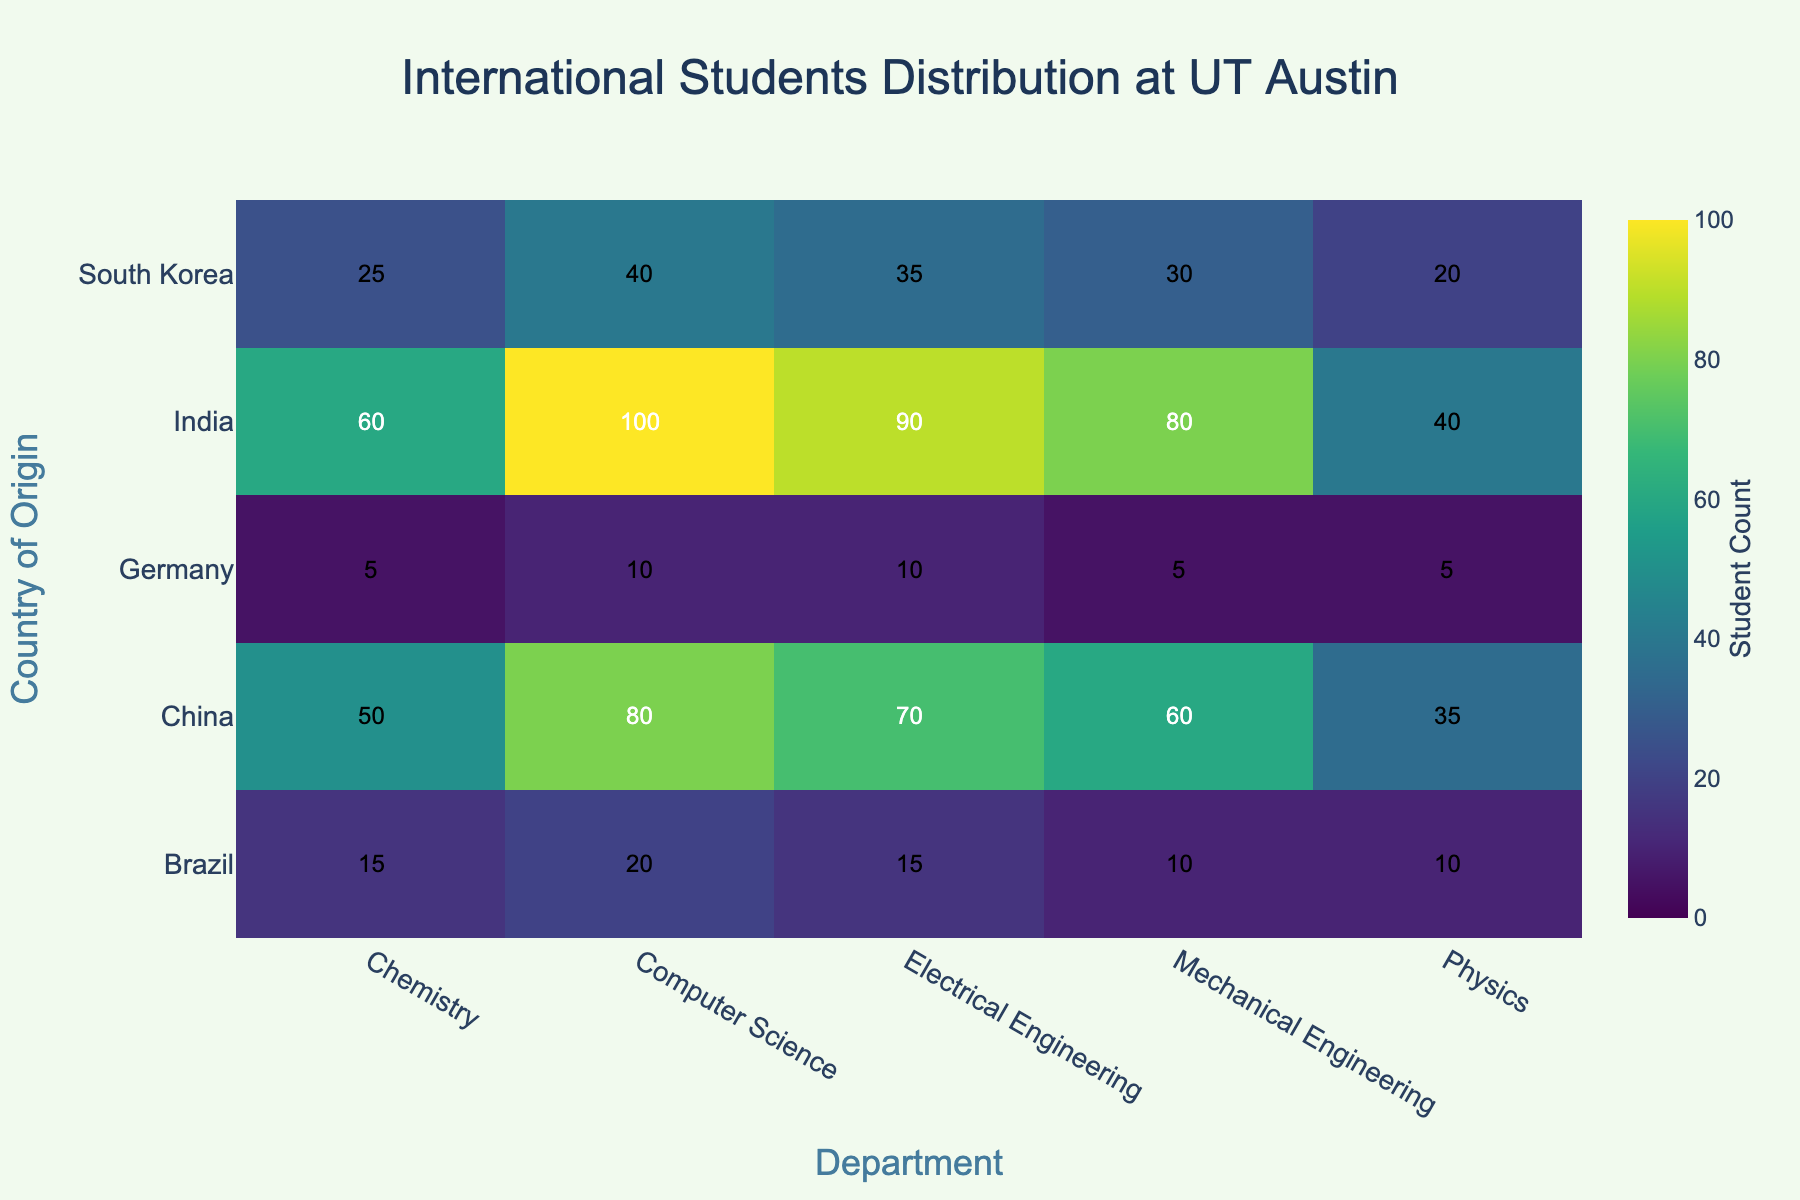What's the title of the heatmap? The title can be found at the top center of the figures. The title is "International Students Distribution at UT Austin" which accurately reflects the data being visualized.
Answer: International Students Distribution at UT Austin Which country has the highest number of students in the Computer Science department? By inspecting the cells corresponding to the Computer Science department, the cell with the highest value belongs to India with a count of 100 students.
Answer: India How many Indian students are enrolled in Chemistry? Look for the cell that intersects at India (on the y-axis) and Chemistry (on the x-axis), where the count is 60 students.
Answer: 60 What is the average number of students from China across all departments? To find the average, add the counts for all departments for China (80 + 70 + 60 + 50 + 35 = 295), and divide by the number of departments (5). So, the average is 295 / 5 = 59.
Answer: 59 Which department has the least number of students from Germany? Identify the smallest count for Germany across all departments. The lowest number is in Mechanical Engineering, with a count of 5.
Answer: Mechanical Engineering How does the number of Brazilian students in Electrical Engineering compare to those in Chemistry? The number of Brazilian students in Electrical Engineering is 15, while in Chemistry it is also 15. So, the counts are equal.
Answer: Equal Which department has the most international students from South Korea? By comparing the cells under each department for South Korea, the Computer Science department has the highest count of 40 students.
Answer: Computer Science What is the total number of international students in the Physics department? Sum the counts from all countries for the Physics department (40 + 35 + 20 + 10 + 5 = 110).
Answer: 110 How many more students are there from India in Computer Science compared to Brazil in the same department? The count for India is 100 and for Brazil is 20. The difference is 100 - 20 = 80 students.
Answer: 80 Which country has a consistent number of students across all departments? By examining the counts, Germany has relatively consistent counts, but no country has exactly the same number across all departments. So, there is no country with equal counts across all departments.
Answer: None 